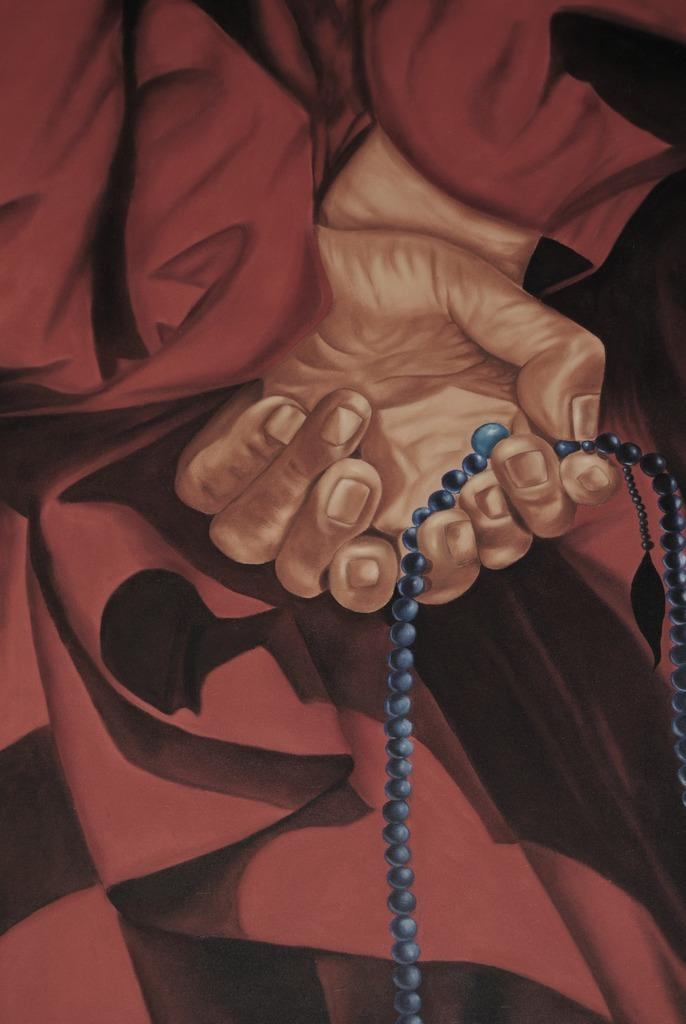What type of artwork is shown in the image? The image is a painting. What is the main subject of the painting? The painting depicts a person's hand. Are there any additional objects or elements in the painting? Yes, there is a beads chain in the painting. How many horses can be seen in the painting? There are no horses depicted in the painting; it features a person's hand and a beads chain. What advice might the person's grandfather give in the painting? There is no person or grandfather present in the painting, as it only depicts a hand and a beads chain. 